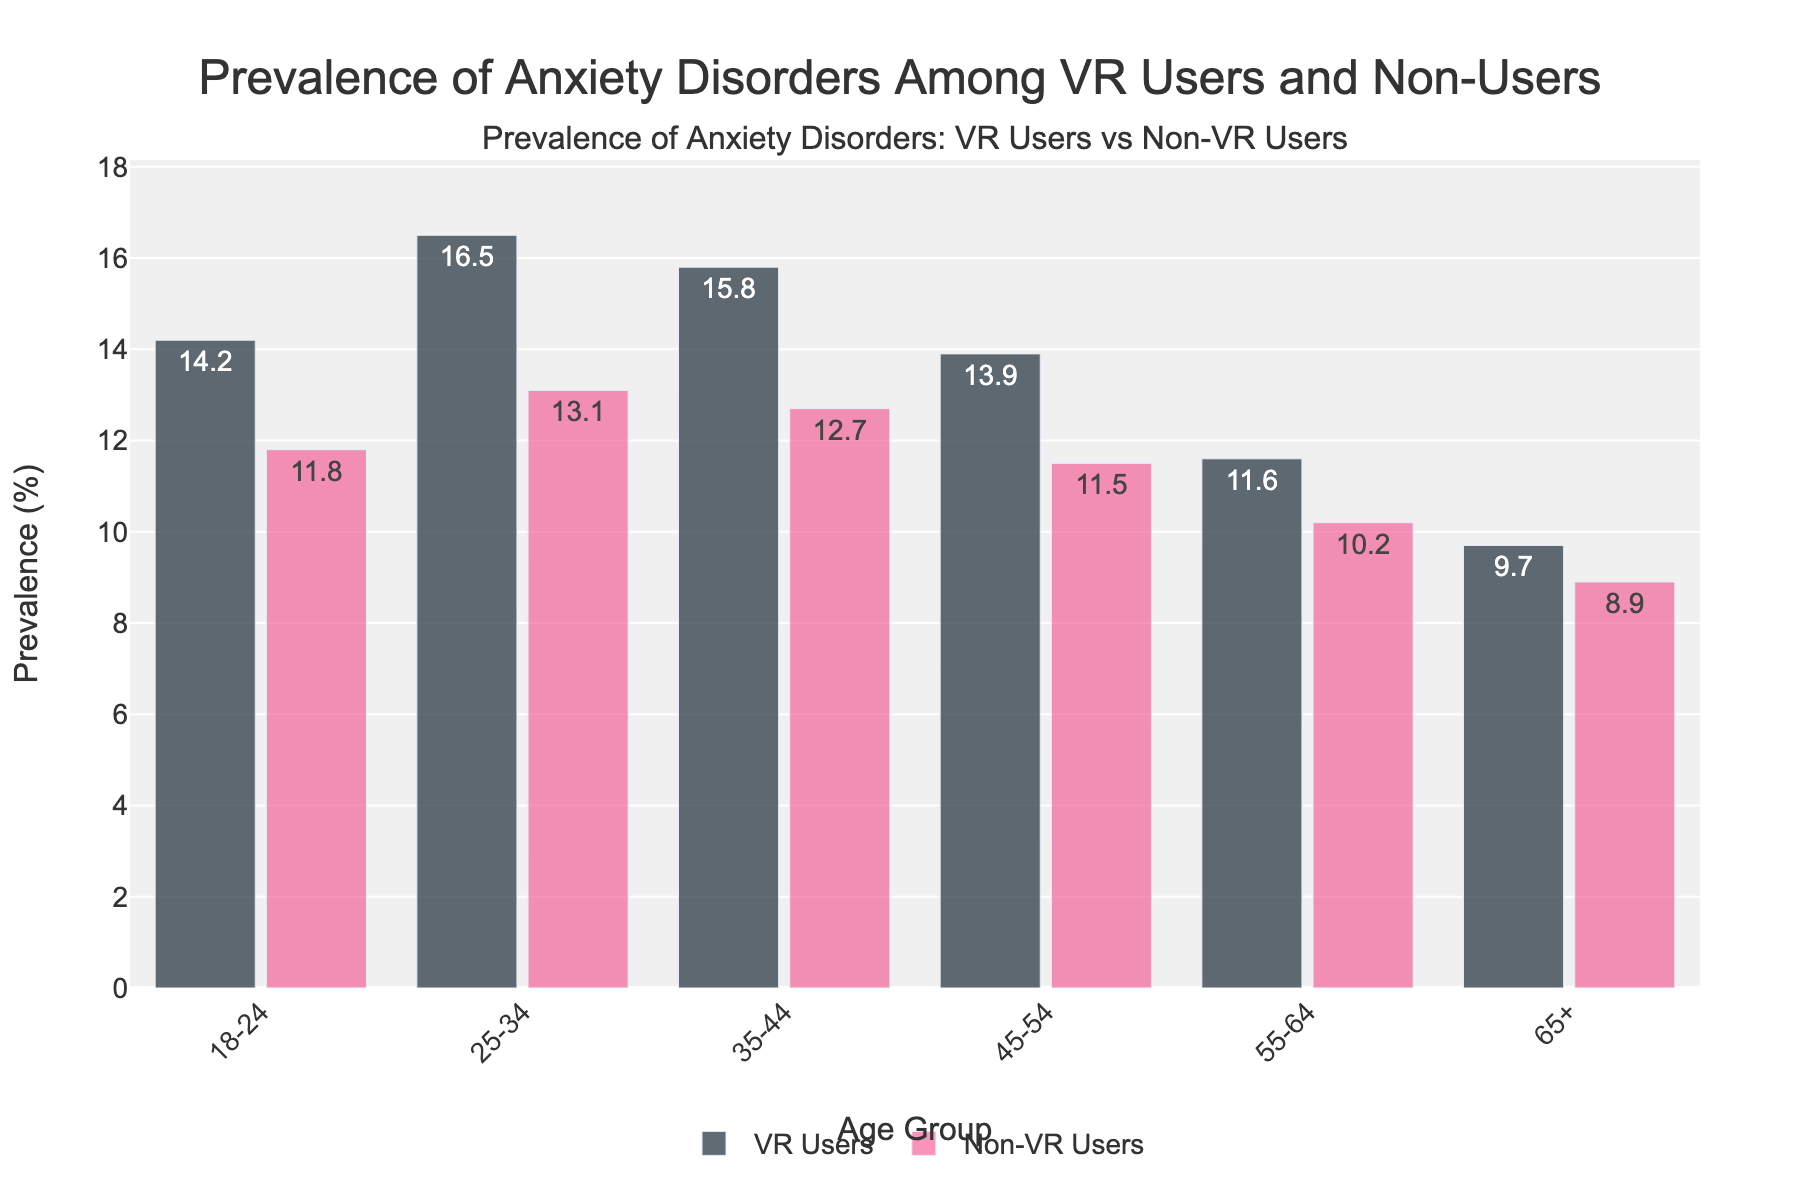Which age group of VR users has the highest prevalence of anxiety disorders? Look at the bar representing VR users and find the tallest bar. The tallest bar corresponds to the age group 25-34 with 16.5%.
Answer: 25-34 Among the non-VR users, which age group has the lowest prevalence of anxiety disorders? Look at the bars representing non-VR users and find the shortest bar. The shortest bar corresponds to the age group 65+ with 8.9%.
Answer: 65+ What is the difference in the prevalence of anxiety disorders between VR users and non-VR users in the 35-44 age group? Subtract the prevalence of non-VR users from VR users in the 35-44 age group: 15.8% (VR users) - 12.7% (non-VR users) = 3.1%.
Answer: 3.1% Which age group has the smallest difference in prevalence rates between VR users and non-VR users? Calculate the differences by subtracting the prevalence of non-VR users from VR users for each age group and find the smallest difference: 18-24 (2.4%), 25-34 (3.4%), 35-44 (3.1%), 45-54 (2.4%), 55-64 (1.4%), 65+ (0.8%). The smallest difference is for the 65+ age group with 0.8%.
Answer: 65+ In which age group do VR users exhibit a prevalence of anxiety disorders higher than 15%? Check where the prevalence bars for VR users are higher than the 15% mark. This occurs in the 25-34 (16.5%) and 35-44 (15.8%) age groups.
Answer: 25-34, 35-44 Compare the prevalence of anxiety disorders among VR users and non-VR users for the 45-54 age group. Observe the heights of the bars for VR users and non-VR users in the 45-54 age group. VR users have a prevalence of 13.9%, while non-VR users have 11.5%.
Answer: VR users: 13.9%, Non-VR users: 11.5% What is the combined prevalence of anxiety disorders among VR users and non-VR users in the 55-64 age group? Add the prevalence rates for VR users and non-VR users in the 55-64 age group: 11.6% (VR users) + 10.2% (non-VR users) = 21.8%.
Answer: 21.8% Which group (VR users or non-VR users) shows a more consistent prevalence of anxiety disorders across all age groups? Look at the range of prevalence rates for both VR users and non-VR users. VR users range from 9.7% to 16.5%, and non-VR users range from 8.9% to 13.1%. Non-VR users have a smaller range (4.2% compared to 6.8%), showing more consistency.
Answer: Non-VR users 